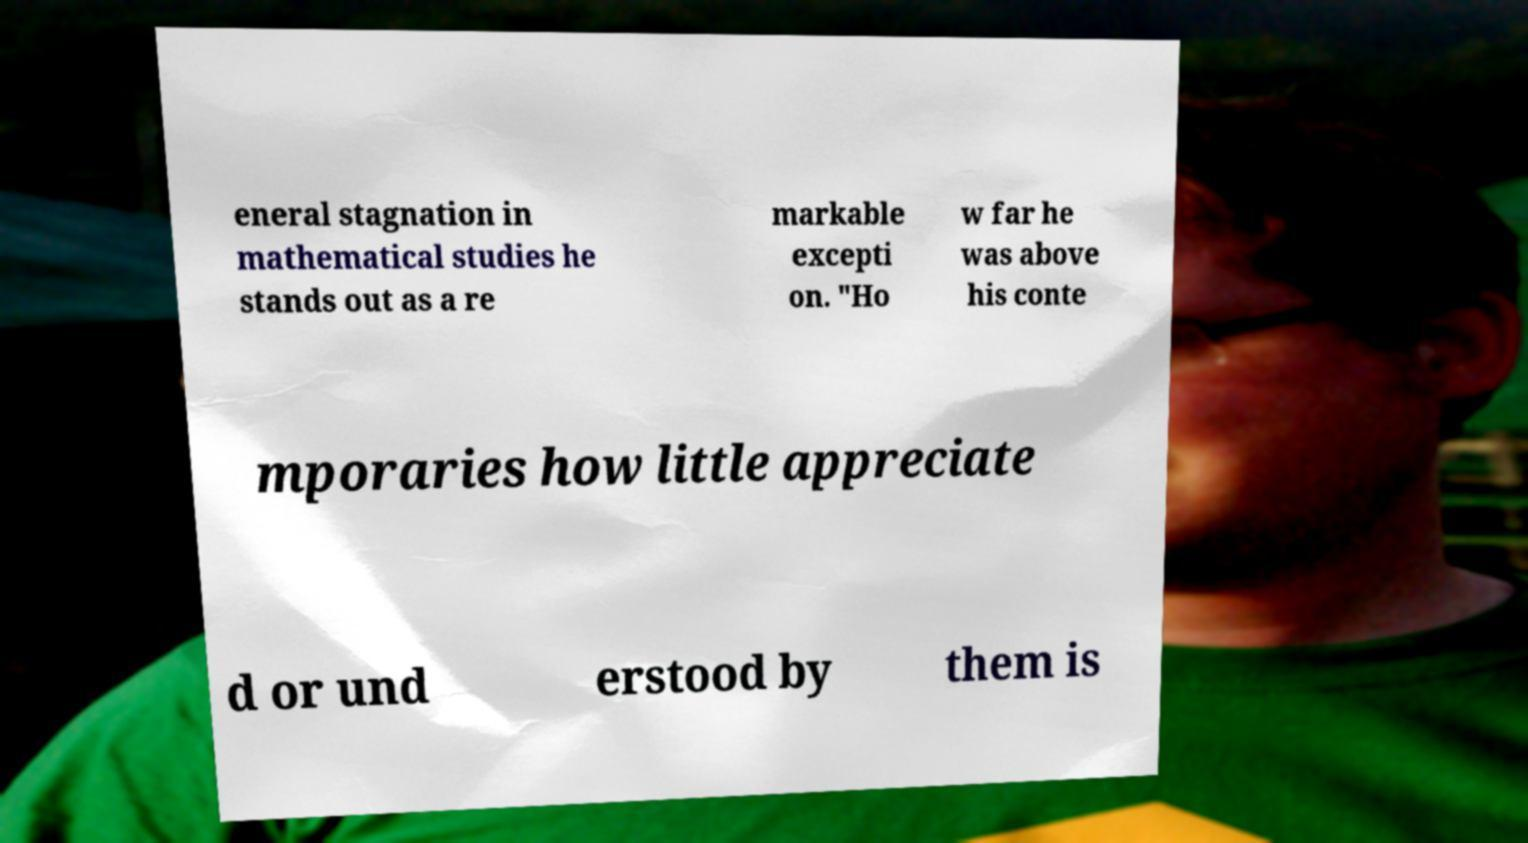There's text embedded in this image that I need extracted. Can you transcribe it verbatim? eneral stagnation in mathematical studies he stands out as a re markable excepti on. "Ho w far he was above his conte mporaries how little appreciate d or und erstood by them is 